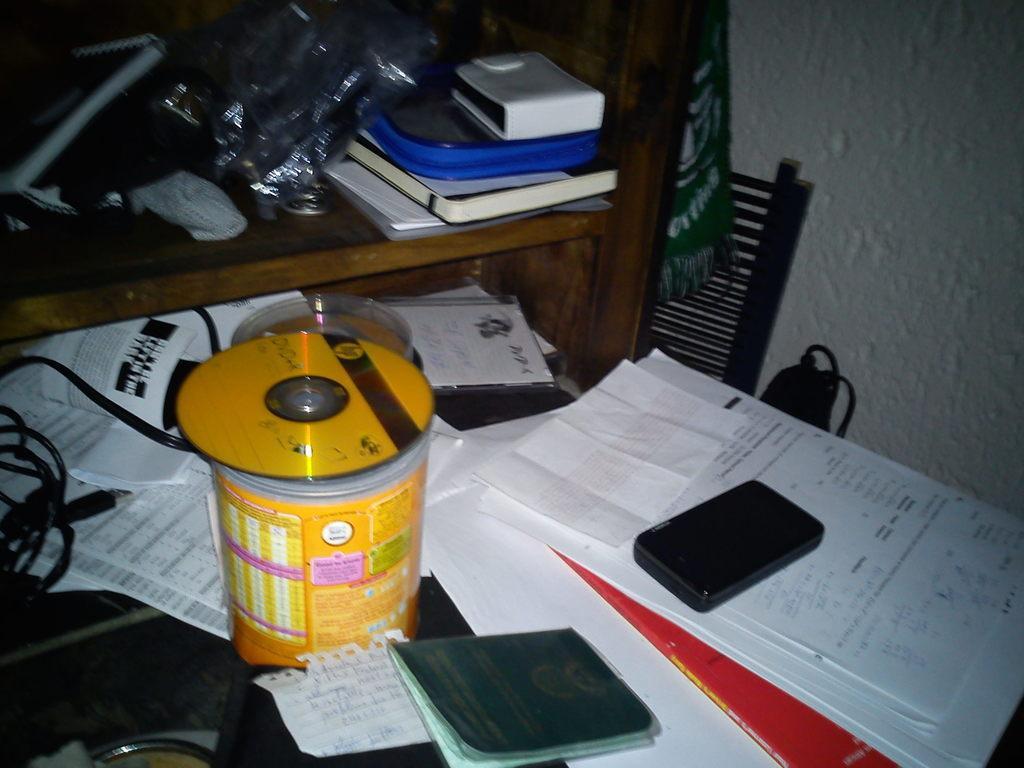Could you give a brief overview of what you see in this image? Here in this picture we can see a table, on which we can see DVDs and its box present and w can also see some books and papers, cable wires and a mobile phone present on it over there and we can see a rack in which we can see covers, books, papers and some hand bags all present in it and beside that we can see a chair and a bag present over there. 